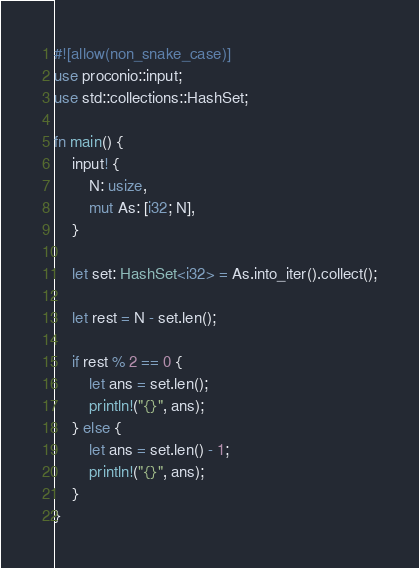Convert code to text. <code><loc_0><loc_0><loc_500><loc_500><_Rust_>#![allow(non_snake_case)]
use proconio::input;
use std::collections::HashSet;

fn main() {
    input! {
        N: usize,
        mut As: [i32; N],
    }

    let set: HashSet<i32> = As.into_iter().collect();

    let rest = N - set.len();

    if rest % 2 == 0 {
        let ans = set.len();
        println!("{}", ans);
    } else {
        let ans = set.len() - 1;
        println!("{}", ans);
    }
}
</code> 